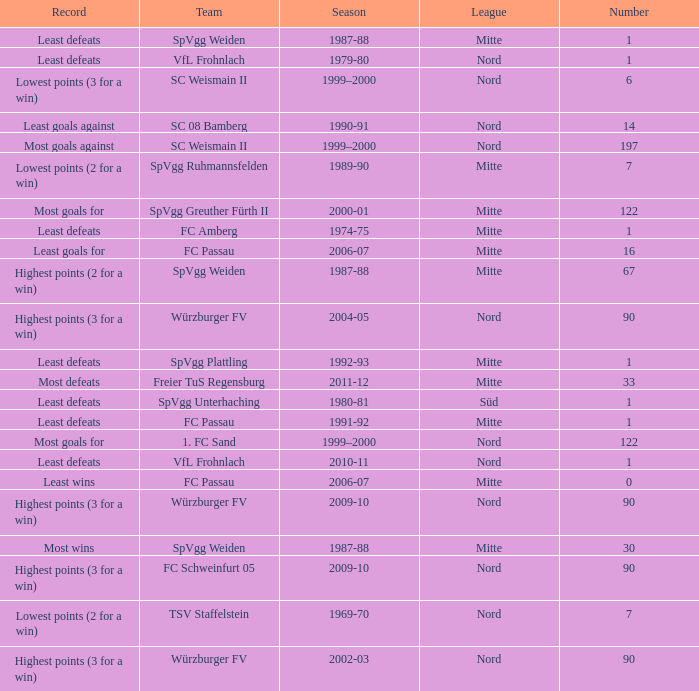What season has a number less than 90, Mitte as the league and spvgg ruhmannsfelden as the team? 1989-90. 